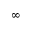Convert formula to latex. <formula><loc_0><loc_0><loc_500><loc_500>\infty</formula> 